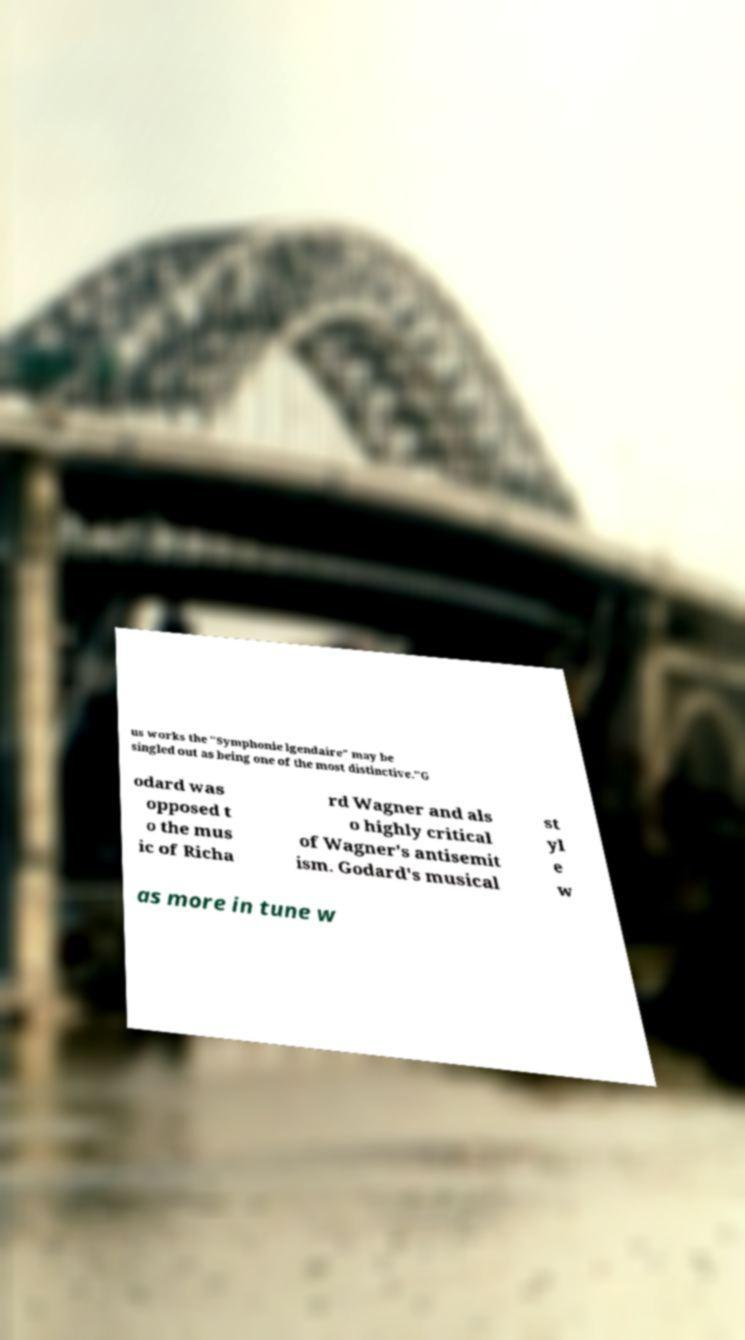For documentation purposes, I need the text within this image transcribed. Could you provide that? us works the "Symphonie lgendaire" may be singled out as being one of the most distinctive."G odard was opposed t o the mus ic of Richa rd Wagner and als o highly critical of Wagner's antisemit ism. Godard's musical st yl e w as more in tune w 